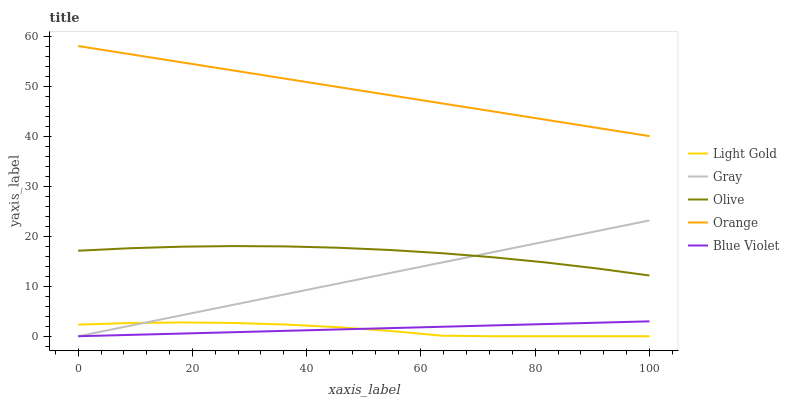Does Light Gold have the minimum area under the curve?
Answer yes or no. Yes. Does Orange have the maximum area under the curve?
Answer yes or no. Yes. Does Gray have the minimum area under the curve?
Answer yes or no. No. Does Gray have the maximum area under the curve?
Answer yes or no. No. Is Blue Violet the smoothest?
Answer yes or no. Yes. Is Light Gold the roughest?
Answer yes or no. Yes. Is Gray the smoothest?
Answer yes or no. No. Is Gray the roughest?
Answer yes or no. No. Does Gray have the lowest value?
Answer yes or no. Yes. Does Orange have the lowest value?
Answer yes or no. No. Does Orange have the highest value?
Answer yes or no. Yes. Does Gray have the highest value?
Answer yes or no. No. Is Blue Violet less than Orange?
Answer yes or no. Yes. Is Orange greater than Gray?
Answer yes or no. Yes. Does Olive intersect Gray?
Answer yes or no. Yes. Is Olive less than Gray?
Answer yes or no. No. Is Olive greater than Gray?
Answer yes or no. No. Does Blue Violet intersect Orange?
Answer yes or no. No. 